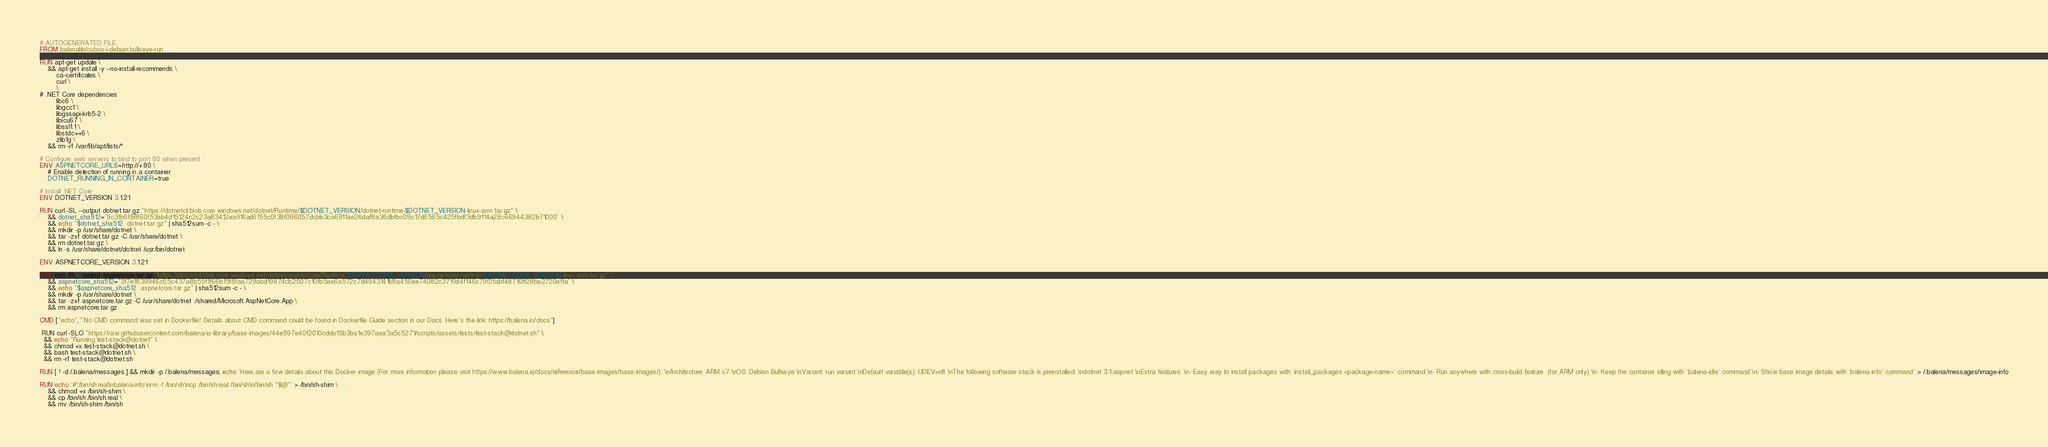Convert code to text. <code><loc_0><loc_0><loc_500><loc_500><_Dockerfile_># AUTOGENERATED FILE
FROM balenalib/cubox-i-debian:bullseye-run

RUN apt-get update \
    && apt-get install -y --no-install-recommends \
        ca-certificates \
        curl \
        \
# .NET Core dependencies
        libc6 \
        libgcc1 \
        libgssapi-krb5-2 \
        libicu67 \
        libssl1.1 \
        libstdc++6 \
        zlib1g \
    && rm -rf /var/lib/apt/lists/*

# Configure web servers to bind to port 80 when present
ENV ASPNETCORE_URLS=http://+:80 \
    # Enable detection of running in a container
    DOTNET_RUNNING_IN_CONTAINER=true

# Install .NET Core
ENV DOTNET_VERSION 3.1.21

RUN curl -SL --output dotnet.tar.gz "https://dotnetcli.blob.core.windows.net/dotnet/Runtime/$DOTNET_VERSION/dotnet-runtime-$DOTNET_VERSION-linux-arm.tar.gz" \
    && dotnet_sha512='9c3fb0f5f860f53ab4d15124c2c23a83412ea916ad6155c0f39f066057dcbb3ca6911ae26daf8a36dbfbc09c17d6565c425fbdf3db9114a28c66944382b71000' \
    && echo "$dotnet_sha512  dotnet.tar.gz" | sha512sum -c - \
    && mkdir -p /usr/share/dotnet \
    && tar -zxf dotnet.tar.gz -C /usr/share/dotnet \
    && rm dotnet.tar.gz \
    && ln -s /usr/share/dotnet/dotnet /usr/bin/dotnet

ENV ASPNETCORE_VERSION 3.1.21

RUN curl -SL --output aspnetcore.tar.gz "https://dotnetcli.blob.core.windows.net/dotnet/aspnetcore/Runtime/$ASPNETCORE_VERSION/aspnetcore-runtime-$ASPNETCORE_VERSION-linux-arm.tar.gz" \
    && aspnetcore_sha512='3f7e1839946c65c437a8b55f1f66b15f8faa729abd19874cb2507c10fb5ae6a572c7d4943141b8a450ee74082c3719d4f146c79f2fabf48716ff28be2720effa' \
    && echo "$aspnetcore_sha512  aspnetcore.tar.gz" | sha512sum -c - \
    && mkdir -p /usr/share/dotnet \
    && tar -zxf aspnetcore.tar.gz -C /usr/share/dotnet ./shared/Microsoft.AspNetCore.App \
    && rm aspnetcore.tar.gz

CMD ["echo","'No CMD command was set in Dockerfile! Details about CMD command could be found in Dockerfile Guide section in our Docs. Here's the link: https://balena.io/docs"]

 RUN curl -SLO "https://raw.githubusercontent.com/balena-io-library/base-images/44e597e40f2010cdde15b3ba1e397aea3a5c5271/scripts/assets/tests/test-stack@dotnet.sh" \
  && echo "Running test-stack@dotnet" \
  && chmod +x test-stack@dotnet.sh \
  && bash test-stack@dotnet.sh \
  && rm -rf test-stack@dotnet.sh 

RUN [ ! -d /.balena/messages ] && mkdir -p /.balena/messages; echo 'Here are a few details about this Docker image (For more information please visit https://www.balena.io/docs/reference/base-images/base-images/): \nArchitecture: ARM v7 \nOS: Debian Bullseye \nVariant: run variant \nDefault variable(s): UDEV=off \nThe following software stack is preinstalled: \ndotnet 3.1-aspnet \nExtra features: \n- Easy way to install packages with `install_packages <package-name>` command \n- Run anywhere with cross-build feature  (for ARM only) \n- Keep the container idling with `balena-idle` command \n- Show base image details with `balena-info` command' > /.balena/messages/image-info

RUN echo '#!/bin/sh.real\nbalena-info\nrm -f /bin/sh\ncp /bin/sh.real /bin/sh\n/bin/sh "$@"' > /bin/sh-shim \
	&& chmod +x /bin/sh-shim \
	&& cp /bin/sh /bin/sh.real \
	&& mv /bin/sh-shim /bin/sh</code> 